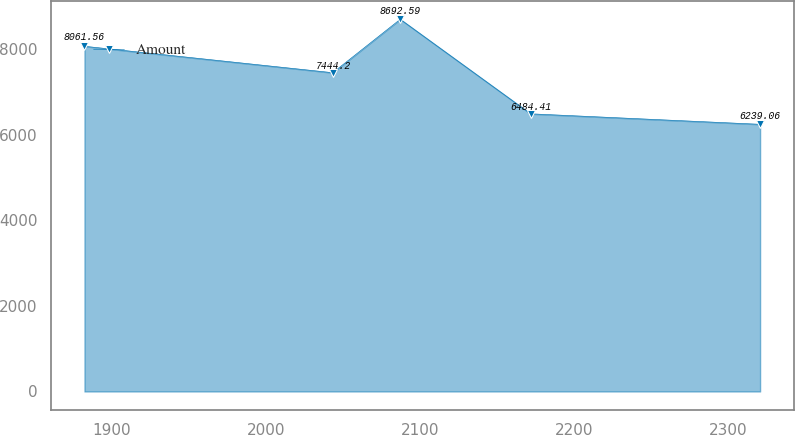<chart> <loc_0><loc_0><loc_500><loc_500><line_chart><ecel><fcel>Amount<nl><fcel>1882.45<fcel>8061.56<nl><fcel>2043.47<fcel>7444.2<nl><fcel>2087.29<fcel>8692.59<nl><fcel>2171.88<fcel>6484.41<nl><fcel>2320.69<fcel>6239.06<nl></chart> 